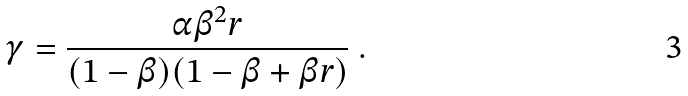Convert formula to latex. <formula><loc_0><loc_0><loc_500><loc_500>\gamma = \frac { \alpha \beta ^ { 2 } r } { ( 1 - \beta ) ( 1 - \beta + \beta r ) } \ .</formula> 